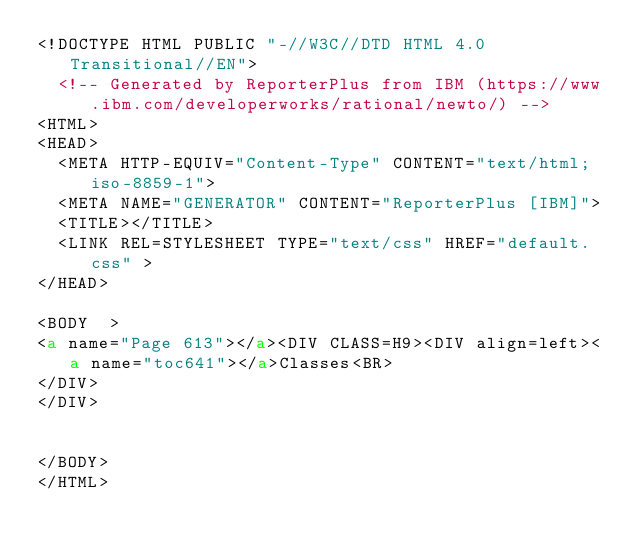<code> <loc_0><loc_0><loc_500><loc_500><_HTML_><!DOCTYPE HTML PUBLIC "-//W3C//DTD HTML 4.0 Transitional//EN">
  <!-- Generated by ReporterPlus from IBM (https://www.ibm.com/developerworks/rational/newto/) -->
<HTML>
<HEAD>
  <META HTTP-EQUIV="Content-Type" CONTENT="text/html; iso-8859-1">
  <META NAME="GENERATOR" CONTENT="ReporterPlus [IBM]">
  <TITLE></TITLE>
  <LINK REL=STYLESHEET TYPE="text/css" HREF="default.css" >
</HEAD>

<BODY  >
<a name="Page 613"></a><DIV CLASS=H9><DIV align=left><a name="toc641"></a>Classes<BR>
</DIV>
</DIV>


</BODY>
</HTML>
</code> 